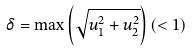<formula> <loc_0><loc_0><loc_500><loc_500>\delta = \max \left ( \sqrt { u _ { 1 } ^ { 2 } + u _ { 2 } ^ { 2 } } \right ) ( < 1 )</formula> 